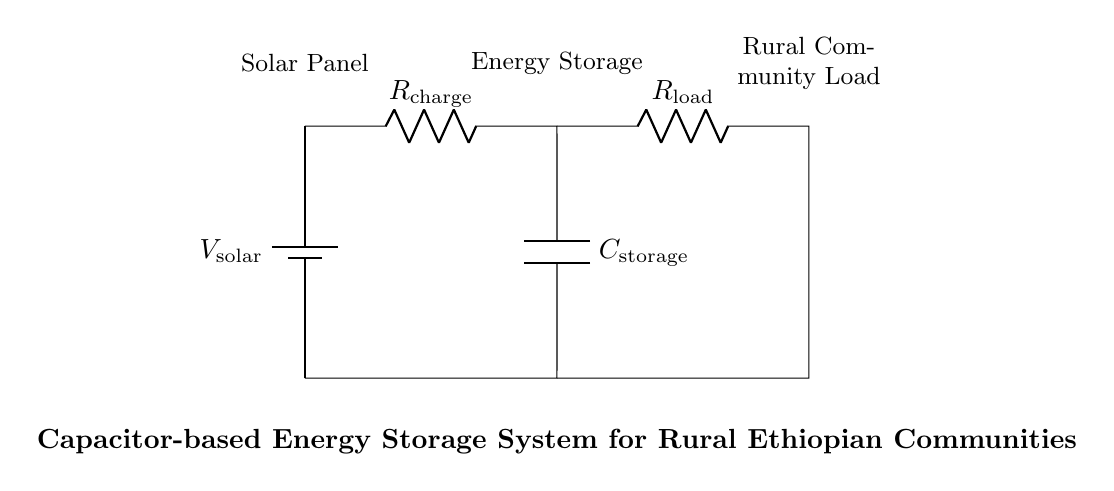What is the type of energy source in this circuit? The energy source depicted is a solar panel, which is indicated by the label associated with the battery symbol at the top left of the diagram.
Answer: Solar panel What is the purpose of the capacitor in this circuit? The capacitor is used for energy storage, allowing the circuit to store energy temporarily before providing it to the load. This is indicated by its labeling as the energy storage component in the diagram.
Answer: Energy storage What is represented by R charge in the circuit? R charge represents the resistor used during the charging phase of the capacitor, controlling the current flow from the solar panel to the capacitor and ensuring proper charging behaviour.
Answer: Resistor for charging What is the relationship between R load and the community? R load is the resistor that represents the load for the rural community, showing how the stored energy in the capacitor is supplied to meet the community's power demands.
Answer: Community load How many main components are identified in the circuit? The circuit includes three main components: the solar panel, the capacitor, and the load resistor, as indicated by their distinct labels in the diagram.
Answer: Three components What happens when the capacitor is fully charged? When the capacitor is fully charged, it reaches its maximum voltage, and it can then provide energy to R load, powering the rural community. This can be inferred from the function of a capacitor in energy storage systems.
Answer: Provides energy to load What does R charge control in this circuit? R charge controls the amount of current flowing into the capacitor from the solar panel, ensuring that the charging process is stable and does not overwhelm the capacitor with excess current.
Answer: Current flow to capacitor 